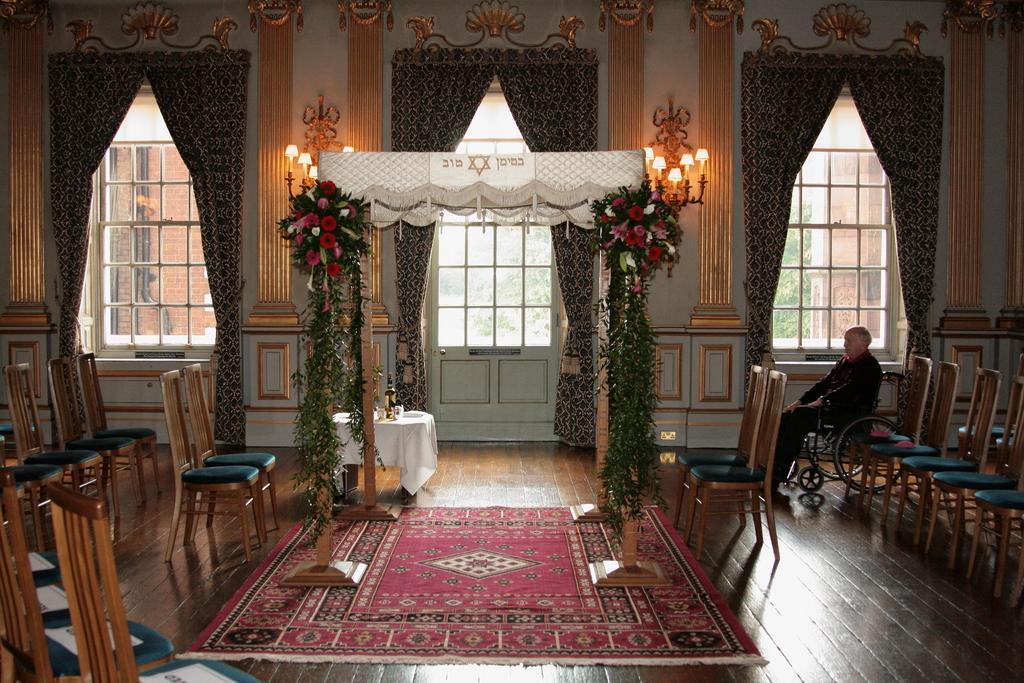Can you describe this image briefly? In this image we can see few chairs, a person sitting on the wheelchair, a carpet on the floor, an arch decorated with flowers and decorative objects, there is a table covered with cloth and few object on it, there are curtains to windows and door, and there are lights to the wall. 